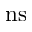Convert formula to latex. <formula><loc_0><loc_0><loc_500><loc_500>n s</formula> 